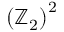Convert formula to latex. <formula><loc_0><loc_0><loc_500><loc_500>\left ( \mathbb { Z } _ { 2 } \right ) ^ { 2 }</formula> 